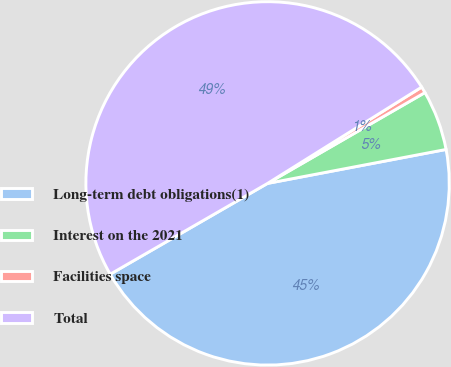Convert chart. <chart><loc_0><loc_0><loc_500><loc_500><pie_chart><fcel>Long-term debt obligations(1)<fcel>Interest on the 2021<fcel>Facilities space<fcel>Total<nl><fcel>44.66%<fcel>5.34%<fcel>0.56%<fcel>49.44%<nl></chart> 